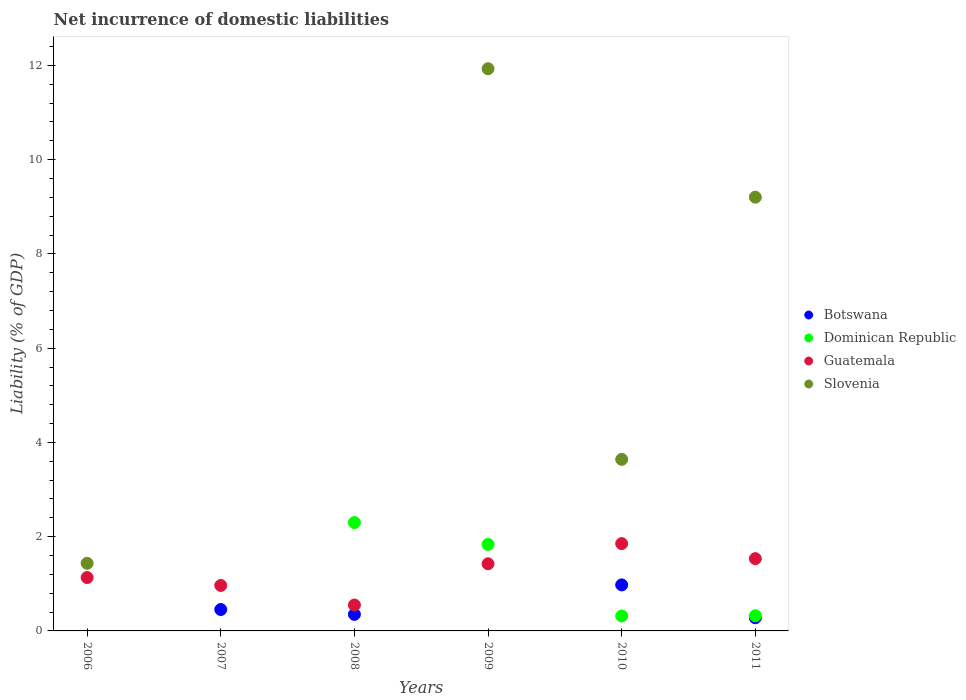How many different coloured dotlines are there?
Provide a succinct answer. 4. Across all years, what is the maximum net incurrence of domestic liabilities in Slovenia?
Provide a succinct answer. 11.93. Across all years, what is the minimum net incurrence of domestic liabilities in Slovenia?
Offer a very short reply. 0. What is the total net incurrence of domestic liabilities in Guatemala in the graph?
Your answer should be very brief. 7.46. What is the difference between the net incurrence of domestic liabilities in Botswana in 2008 and that in 2010?
Provide a succinct answer. -0.63. What is the difference between the net incurrence of domestic liabilities in Botswana in 2010 and the net incurrence of domestic liabilities in Dominican Republic in 2007?
Provide a succinct answer. 0.98. What is the average net incurrence of domestic liabilities in Slovenia per year?
Offer a terse response. 4.37. In the year 2010, what is the difference between the net incurrence of domestic liabilities in Dominican Republic and net incurrence of domestic liabilities in Guatemala?
Your answer should be compact. -1.54. What is the ratio of the net incurrence of domestic liabilities in Guatemala in 2008 to that in 2010?
Ensure brevity in your answer.  0.3. Is the net incurrence of domestic liabilities in Dominican Republic in 2010 less than that in 2011?
Your answer should be compact. Yes. What is the difference between the highest and the second highest net incurrence of domestic liabilities in Dominican Republic?
Make the answer very short. 0.46. What is the difference between the highest and the lowest net incurrence of domestic liabilities in Guatemala?
Your response must be concise. 1.3. In how many years, is the net incurrence of domestic liabilities in Botswana greater than the average net incurrence of domestic liabilities in Botswana taken over all years?
Your response must be concise. 3. Is it the case that in every year, the sum of the net incurrence of domestic liabilities in Slovenia and net incurrence of domestic liabilities in Dominican Republic  is greater than the net incurrence of domestic liabilities in Guatemala?
Provide a short and direct response. No. Does the net incurrence of domestic liabilities in Botswana monotonically increase over the years?
Your response must be concise. No. Is the net incurrence of domestic liabilities in Botswana strictly less than the net incurrence of domestic liabilities in Guatemala over the years?
Ensure brevity in your answer.  Yes. How many years are there in the graph?
Your answer should be very brief. 6. Does the graph contain any zero values?
Your response must be concise. Yes. Where does the legend appear in the graph?
Give a very brief answer. Center right. How are the legend labels stacked?
Make the answer very short. Vertical. What is the title of the graph?
Make the answer very short. Net incurrence of domestic liabilities. Does "Pakistan" appear as one of the legend labels in the graph?
Keep it short and to the point. No. What is the label or title of the Y-axis?
Ensure brevity in your answer.  Liability (% of GDP). What is the Liability (% of GDP) in Botswana in 2006?
Your answer should be compact. 0. What is the Liability (% of GDP) in Guatemala in 2006?
Your answer should be compact. 1.13. What is the Liability (% of GDP) of Slovenia in 2006?
Your response must be concise. 1.43. What is the Liability (% of GDP) in Botswana in 2007?
Provide a short and direct response. 0.45. What is the Liability (% of GDP) of Guatemala in 2007?
Your answer should be compact. 0.96. What is the Liability (% of GDP) of Botswana in 2008?
Offer a terse response. 0.35. What is the Liability (% of GDP) in Dominican Republic in 2008?
Your answer should be compact. 2.3. What is the Liability (% of GDP) of Guatemala in 2008?
Your response must be concise. 0.55. What is the Liability (% of GDP) in Slovenia in 2008?
Ensure brevity in your answer.  0. What is the Liability (% of GDP) of Dominican Republic in 2009?
Provide a succinct answer. 1.84. What is the Liability (% of GDP) of Guatemala in 2009?
Keep it short and to the point. 1.42. What is the Liability (% of GDP) in Slovenia in 2009?
Offer a very short reply. 11.93. What is the Liability (% of GDP) of Botswana in 2010?
Provide a short and direct response. 0.98. What is the Liability (% of GDP) of Dominican Republic in 2010?
Your answer should be compact. 0.32. What is the Liability (% of GDP) of Guatemala in 2010?
Provide a succinct answer. 1.85. What is the Liability (% of GDP) of Slovenia in 2010?
Give a very brief answer. 3.64. What is the Liability (% of GDP) of Botswana in 2011?
Offer a terse response. 0.28. What is the Liability (% of GDP) in Dominican Republic in 2011?
Provide a short and direct response. 0.32. What is the Liability (% of GDP) in Guatemala in 2011?
Provide a succinct answer. 1.53. What is the Liability (% of GDP) of Slovenia in 2011?
Offer a very short reply. 9.2. Across all years, what is the maximum Liability (% of GDP) in Botswana?
Your answer should be very brief. 0.98. Across all years, what is the maximum Liability (% of GDP) of Dominican Republic?
Your answer should be very brief. 2.3. Across all years, what is the maximum Liability (% of GDP) in Guatemala?
Provide a succinct answer. 1.85. Across all years, what is the maximum Liability (% of GDP) in Slovenia?
Ensure brevity in your answer.  11.93. Across all years, what is the minimum Liability (% of GDP) of Guatemala?
Your response must be concise. 0.55. What is the total Liability (% of GDP) in Botswana in the graph?
Keep it short and to the point. 2.06. What is the total Liability (% of GDP) in Dominican Republic in the graph?
Your response must be concise. 4.77. What is the total Liability (% of GDP) of Guatemala in the graph?
Give a very brief answer. 7.46. What is the total Liability (% of GDP) of Slovenia in the graph?
Offer a very short reply. 26.21. What is the difference between the Liability (% of GDP) of Guatemala in 2006 and that in 2007?
Offer a terse response. 0.17. What is the difference between the Liability (% of GDP) in Guatemala in 2006 and that in 2008?
Provide a short and direct response. 0.58. What is the difference between the Liability (% of GDP) in Guatemala in 2006 and that in 2009?
Ensure brevity in your answer.  -0.29. What is the difference between the Liability (% of GDP) in Slovenia in 2006 and that in 2009?
Keep it short and to the point. -10.5. What is the difference between the Liability (% of GDP) of Guatemala in 2006 and that in 2010?
Your answer should be compact. -0.72. What is the difference between the Liability (% of GDP) of Slovenia in 2006 and that in 2010?
Offer a terse response. -2.21. What is the difference between the Liability (% of GDP) in Guatemala in 2006 and that in 2011?
Ensure brevity in your answer.  -0.4. What is the difference between the Liability (% of GDP) of Slovenia in 2006 and that in 2011?
Your response must be concise. -7.77. What is the difference between the Liability (% of GDP) of Botswana in 2007 and that in 2008?
Your response must be concise. 0.1. What is the difference between the Liability (% of GDP) of Guatemala in 2007 and that in 2008?
Your response must be concise. 0.42. What is the difference between the Liability (% of GDP) in Guatemala in 2007 and that in 2009?
Your answer should be very brief. -0.46. What is the difference between the Liability (% of GDP) in Botswana in 2007 and that in 2010?
Offer a terse response. -0.52. What is the difference between the Liability (% of GDP) in Guatemala in 2007 and that in 2010?
Keep it short and to the point. -0.89. What is the difference between the Liability (% of GDP) of Botswana in 2007 and that in 2011?
Your response must be concise. 0.17. What is the difference between the Liability (% of GDP) of Guatemala in 2007 and that in 2011?
Offer a very short reply. -0.57. What is the difference between the Liability (% of GDP) of Dominican Republic in 2008 and that in 2009?
Offer a very short reply. 0.46. What is the difference between the Liability (% of GDP) in Guatemala in 2008 and that in 2009?
Offer a very short reply. -0.88. What is the difference between the Liability (% of GDP) of Botswana in 2008 and that in 2010?
Give a very brief answer. -0.63. What is the difference between the Liability (% of GDP) in Dominican Republic in 2008 and that in 2010?
Your answer should be compact. 1.98. What is the difference between the Liability (% of GDP) in Guatemala in 2008 and that in 2010?
Make the answer very short. -1.3. What is the difference between the Liability (% of GDP) in Botswana in 2008 and that in 2011?
Offer a terse response. 0.07. What is the difference between the Liability (% of GDP) of Dominican Republic in 2008 and that in 2011?
Keep it short and to the point. 1.98. What is the difference between the Liability (% of GDP) of Guatemala in 2008 and that in 2011?
Provide a short and direct response. -0.98. What is the difference between the Liability (% of GDP) of Dominican Republic in 2009 and that in 2010?
Your response must be concise. 1.52. What is the difference between the Liability (% of GDP) in Guatemala in 2009 and that in 2010?
Give a very brief answer. -0.43. What is the difference between the Liability (% of GDP) in Slovenia in 2009 and that in 2010?
Ensure brevity in your answer.  8.29. What is the difference between the Liability (% of GDP) of Dominican Republic in 2009 and that in 2011?
Provide a succinct answer. 1.51. What is the difference between the Liability (% of GDP) in Guatemala in 2009 and that in 2011?
Your answer should be compact. -0.11. What is the difference between the Liability (% of GDP) of Slovenia in 2009 and that in 2011?
Offer a very short reply. 2.73. What is the difference between the Liability (% of GDP) in Botswana in 2010 and that in 2011?
Ensure brevity in your answer.  0.7. What is the difference between the Liability (% of GDP) in Dominican Republic in 2010 and that in 2011?
Make the answer very short. -0. What is the difference between the Liability (% of GDP) of Guatemala in 2010 and that in 2011?
Keep it short and to the point. 0.32. What is the difference between the Liability (% of GDP) in Slovenia in 2010 and that in 2011?
Keep it short and to the point. -5.56. What is the difference between the Liability (% of GDP) of Guatemala in 2006 and the Liability (% of GDP) of Slovenia in 2009?
Offer a terse response. -10.8. What is the difference between the Liability (% of GDP) of Guatemala in 2006 and the Liability (% of GDP) of Slovenia in 2010?
Ensure brevity in your answer.  -2.51. What is the difference between the Liability (% of GDP) of Guatemala in 2006 and the Liability (% of GDP) of Slovenia in 2011?
Offer a terse response. -8.07. What is the difference between the Liability (% of GDP) in Botswana in 2007 and the Liability (% of GDP) in Dominican Republic in 2008?
Offer a terse response. -1.84. What is the difference between the Liability (% of GDP) of Botswana in 2007 and the Liability (% of GDP) of Guatemala in 2008?
Provide a short and direct response. -0.1. What is the difference between the Liability (% of GDP) of Botswana in 2007 and the Liability (% of GDP) of Dominican Republic in 2009?
Give a very brief answer. -1.38. What is the difference between the Liability (% of GDP) of Botswana in 2007 and the Liability (% of GDP) of Guatemala in 2009?
Your answer should be very brief. -0.97. What is the difference between the Liability (% of GDP) of Botswana in 2007 and the Liability (% of GDP) of Slovenia in 2009?
Offer a very short reply. -11.48. What is the difference between the Liability (% of GDP) in Guatemala in 2007 and the Liability (% of GDP) in Slovenia in 2009?
Provide a succinct answer. -10.97. What is the difference between the Liability (% of GDP) of Botswana in 2007 and the Liability (% of GDP) of Dominican Republic in 2010?
Provide a short and direct response. 0.14. What is the difference between the Liability (% of GDP) of Botswana in 2007 and the Liability (% of GDP) of Guatemala in 2010?
Give a very brief answer. -1.4. What is the difference between the Liability (% of GDP) in Botswana in 2007 and the Liability (% of GDP) in Slovenia in 2010?
Provide a succinct answer. -3.19. What is the difference between the Liability (% of GDP) of Guatemala in 2007 and the Liability (% of GDP) of Slovenia in 2010?
Ensure brevity in your answer.  -2.68. What is the difference between the Liability (% of GDP) of Botswana in 2007 and the Liability (% of GDP) of Dominican Republic in 2011?
Ensure brevity in your answer.  0.13. What is the difference between the Liability (% of GDP) in Botswana in 2007 and the Liability (% of GDP) in Guatemala in 2011?
Offer a very short reply. -1.08. What is the difference between the Liability (% of GDP) of Botswana in 2007 and the Liability (% of GDP) of Slovenia in 2011?
Your answer should be compact. -8.75. What is the difference between the Liability (% of GDP) of Guatemala in 2007 and the Liability (% of GDP) of Slovenia in 2011?
Offer a very short reply. -8.24. What is the difference between the Liability (% of GDP) in Botswana in 2008 and the Liability (% of GDP) in Dominican Republic in 2009?
Ensure brevity in your answer.  -1.48. What is the difference between the Liability (% of GDP) in Botswana in 2008 and the Liability (% of GDP) in Guatemala in 2009?
Your answer should be very brief. -1.07. What is the difference between the Liability (% of GDP) of Botswana in 2008 and the Liability (% of GDP) of Slovenia in 2009?
Your answer should be very brief. -11.58. What is the difference between the Liability (% of GDP) in Dominican Republic in 2008 and the Liability (% of GDP) in Guatemala in 2009?
Your response must be concise. 0.87. What is the difference between the Liability (% of GDP) of Dominican Republic in 2008 and the Liability (% of GDP) of Slovenia in 2009?
Keep it short and to the point. -9.63. What is the difference between the Liability (% of GDP) of Guatemala in 2008 and the Liability (% of GDP) of Slovenia in 2009?
Provide a succinct answer. -11.38. What is the difference between the Liability (% of GDP) of Botswana in 2008 and the Liability (% of GDP) of Dominican Republic in 2010?
Provide a short and direct response. 0.03. What is the difference between the Liability (% of GDP) in Botswana in 2008 and the Liability (% of GDP) in Guatemala in 2010?
Make the answer very short. -1.5. What is the difference between the Liability (% of GDP) of Botswana in 2008 and the Liability (% of GDP) of Slovenia in 2010?
Your answer should be very brief. -3.29. What is the difference between the Liability (% of GDP) of Dominican Republic in 2008 and the Liability (% of GDP) of Guatemala in 2010?
Give a very brief answer. 0.45. What is the difference between the Liability (% of GDP) of Dominican Republic in 2008 and the Liability (% of GDP) of Slovenia in 2010?
Make the answer very short. -1.34. What is the difference between the Liability (% of GDP) in Guatemala in 2008 and the Liability (% of GDP) in Slovenia in 2010?
Provide a succinct answer. -3.09. What is the difference between the Liability (% of GDP) of Botswana in 2008 and the Liability (% of GDP) of Dominican Republic in 2011?
Provide a succinct answer. 0.03. What is the difference between the Liability (% of GDP) of Botswana in 2008 and the Liability (% of GDP) of Guatemala in 2011?
Make the answer very short. -1.18. What is the difference between the Liability (% of GDP) in Botswana in 2008 and the Liability (% of GDP) in Slovenia in 2011?
Provide a succinct answer. -8.85. What is the difference between the Liability (% of GDP) of Dominican Republic in 2008 and the Liability (% of GDP) of Guatemala in 2011?
Your answer should be very brief. 0.77. What is the difference between the Liability (% of GDP) in Dominican Republic in 2008 and the Liability (% of GDP) in Slovenia in 2011?
Your answer should be very brief. -6.9. What is the difference between the Liability (% of GDP) of Guatemala in 2008 and the Liability (% of GDP) of Slovenia in 2011?
Offer a very short reply. -8.65. What is the difference between the Liability (% of GDP) in Dominican Republic in 2009 and the Liability (% of GDP) in Guatemala in 2010?
Provide a succinct answer. -0.02. What is the difference between the Liability (% of GDP) in Dominican Republic in 2009 and the Liability (% of GDP) in Slovenia in 2010?
Your answer should be compact. -1.8. What is the difference between the Liability (% of GDP) of Guatemala in 2009 and the Liability (% of GDP) of Slovenia in 2010?
Your response must be concise. -2.22. What is the difference between the Liability (% of GDP) in Dominican Republic in 2009 and the Liability (% of GDP) in Guatemala in 2011?
Your answer should be compact. 0.3. What is the difference between the Liability (% of GDP) of Dominican Republic in 2009 and the Liability (% of GDP) of Slovenia in 2011?
Provide a succinct answer. -7.37. What is the difference between the Liability (% of GDP) in Guatemala in 2009 and the Liability (% of GDP) in Slovenia in 2011?
Offer a very short reply. -7.78. What is the difference between the Liability (% of GDP) of Botswana in 2010 and the Liability (% of GDP) of Dominican Republic in 2011?
Your answer should be compact. 0.66. What is the difference between the Liability (% of GDP) of Botswana in 2010 and the Liability (% of GDP) of Guatemala in 2011?
Provide a short and direct response. -0.56. What is the difference between the Liability (% of GDP) in Botswana in 2010 and the Liability (% of GDP) in Slovenia in 2011?
Offer a very short reply. -8.23. What is the difference between the Liability (% of GDP) of Dominican Republic in 2010 and the Liability (% of GDP) of Guatemala in 2011?
Provide a succinct answer. -1.22. What is the difference between the Liability (% of GDP) in Dominican Republic in 2010 and the Liability (% of GDP) in Slovenia in 2011?
Ensure brevity in your answer.  -8.89. What is the difference between the Liability (% of GDP) in Guatemala in 2010 and the Liability (% of GDP) in Slovenia in 2011?
Your answer should be very brief. -7.35. What is the average Liability (% of GDP) of Botswana per year?
Offer a very short reply. 0.34. What is the average Liability (% of GDP) in Dominican Republic per year?
Provide a short and direct response. 0.8. What is the average Liability (% of GDP) of Guatemala per year?
Provide a succinct answer. 1.24. What is the average Liability (% of GDP) of Slovenia per year?
Offer a terse response. 4.37. In the year 2006, what is the difference between the Liability (% of GDP) in Guatemala and Liability (% of GDP) in Slovenia?
Your response must be concise. -0.3. In the year 2007, what is the difference between the Liability (% of GDP) of Botswana and Liability (% of GDP) of Guatemala?
Keep it short and to the point. -0.51. In the year 2008, what is the difference between the Liability (% of GDP) in Botswana and Liability (% of GDP) in Dominican Republic?
Your answer should be compact. -1.95. In the year 2008, what is the difference between the Liability (% of GDP) in Botswana and Liability (% of GDP) in Guatemala?
Provide a short and direct response. -0.2. In the year 2008, what is the difference between the Liability (% of GDP) in Dominican Republic and Liability (% of GDP) in Guatemala?
Your response must be concise. 1.75. In the year 2009, what is the difference between the Liability (% of GDP) of Dominican Republic and Liability (% of GDP) of Guatemala?
Offer a very short reply. 0.41. In the year 2009, what is the difference between the Liability (% of GDP) of Dominican Republic and Liability (% of GDP) of Slovenia?
Keep it short and to the point. -10.09. In the year 2009, what is the difference between the Liability (% of GDP) of Guatemala and Liability (% of GDP) of Slovenia?
Ensure brevity in your answer.  -10.51. In the year 2010, what is the difference between the Liability (% of GDP) in Botswana and Liability (% of GDP) in Dominican Republic?
Keep it short and to the point. 0.66. In the year 2010, what is the difference between the Liability (% of GDP) of Botswana and Liability (% of GDP) of Guatemala?
Your answer should be very brief. -0.88. In the year 2010, what is the difference between the Liability (% of GDP) in Botswana and Liability (% of GDP) in Slovenia?
Give a very brief answer. -2.66. In the year 2010, what is the difference between the Liability (% of GDP) of Dominican Republic and Liability (% of GDP) of Guatemala?
Provide a short and direct response. -1.54. In the year 2010, what is the difference between the Liability (% of GDP) of Dominican Republic and Liability (% of GDP) of Slovenia?
Offer a terse response. -3.32. In the year 2010, what is the difference between the Liability (% of GDP) in Guatemala and Liability (% of GDP) in Slovenia?
Make the answer very short. -1.79. In the year 2011, what is the difference between the Liability (% of GDP) of Botswana and Liability (% of GDP) of Dominican Republic?
Provide a short and direct response. -0.04. In the year 2011, what is the difference between the Liability (% of GDP) of Botswana and Liability (% of GDP) of Guatemala?
Your answer should be compact. -1.25. In the year 2011, what is the difference between the Liability (% of GDP) in Botswana and Liability (% of GDP) in Slovenia?
Your response must be concise. -8.92. In the year 2011, what is the difference between the Liability (% of GDP) in Dominican Republic and Liability (% of GDP) in Guatemala?
Give a very brief answer. -1.21. In the year 2011, what is the difference between the Liability (% of GDP) in Dominican Republic and Liability (% of GDP) in Slovenia?
Offer a terse response. -8.88. In the year 2011, what is the difference between the Liability (% of GDP) in Guatemala and Liability (% of GDP) in Slovenia?
Provide a short and direct response. -7.67. What is the ratio of the Liability (% of GDP) in Guatemala in 2006 to that in 2007?
Your answer should be very brief. 1.17. What is the ratio of the Liability (% of GDP) of Guatemala in 2006 to that in 2008?
Provide a short and direct response. 2.06. What is the ratio of the Liability (% of GDP) of Guatemala in 2006 to that in 2009?
Your answer should be compact. 0.8. What is the ratio of the Liability (% of GDP) in Slovenia in 2006 to that in 2009?
Offer a terse response. 0.12. What is the ratio of the Liability (% of GDP) in Guatemala in 2006 to that in 2010?
Provide a succinct answer. 0.61. What is the ratio of the Liability (% of GDP) in Slovenia in 2006 to that in 2010?
Your answer should be compact. 0.39. What is the ratio of the Liability (% of GDP) of Guatemala in 2006 to that in 2011?
Keep it short and to the point. 0.74. What is the ratio of the Liability (% of GDP) in Slovenia in 2006 to that in 2011?
Offer a very short reply. 0.16. What is the ratio of the Liability (% of GDP) in Botswana in 2007 to that in 2008?
Offer a very short reply. 1.29. What is the ratio of the Liability (% of GDP) of Guatemala in 2007 to that in 2008?
Your answer should be compact. 1.76. What is the ratio of the Liability (% of GDP) in Guatemala in 2007 to that in 2009?
Your answer should be compact. 0.68. What is the ratio of the Liability (% of GDP) of Botswana in 2007 to that in 2010?
Make the answer very short. 0.46. What is the ratio of the Liability (% of GDP) in Guatemala in 2007 to that in 2010?
Make the answer very short. 0.52. What is the ratio of the Liability (% of GDP) in Botswana in 2007 to that in 2011?
Provide a short and direct response. 1.62. What is the ratio of the Liability (% of GDP) in Guatemala in 2007 to that in 2011?
Your answer should be compact. 0.63. What is the ratio of the Liability (% of GDP) in Dominican Republic in 2008 to that in 2009?
Your answer should be very brief. 1.25. What is the ratio of the Liability (% of GDP) of Guatemala in 2008 to that in 2009?
Offer a very short reply. 0.39. What is the ratio of the Liability (% of GDP) of Botswana in 2008 to that in 2010?
Offer a very short reply. 0.36. What is the ratio of the Liability (% of GDP) of Dominican Republic in 2008 to that in 2010?
Offer a very short reply. 7.25. What is the ratio of the Liability (% of GDP) of Guatemala in 2008 to that in 2010?
Keep it short and to the point. 0.3. What is the ratio of the Liability (% of GDP) of Botswana in 2008 to that in 2011?
Your answer should be compact. 1.26. What is the ratio of the Liability (% of GDP) in Dominican Republic in 2008 to that in 2011?
Provide a succinct answer. 7.16. What is the ratio of the Liability (% of GDP) of Guatemala in 2008 to that in 2011?
Ensure brevity in your answer.  0.36. What is the ratio of the Liability (% of GDP) in Dominican Republic in 2009 to that in 2010?
Provide a short and direct response. 5.79. What is the ratio of the Liability (% of GDP) in Guatemala in 2009 to that in 2010?
Provide a short and direct response. 0.77. What is the ratio of the Liability (% of GDP) in Slovenia in 2009 to that in 2010?
Provide a short and direct response. 3.28. What is the ratio of the Liability (% of GDP) of Dominican Republic in 2009 to that in 2011?
Your response must be concise. 5.72. What is the ratio of the Liability (% of GDP) in Guatemala in 2009 to that in 2011?
Your answer should be very brief. 0.93. What is the ratio of the Liability (% of GDP) in Slovenia in 2009 to that in 2011?
Make the answer very short. 1.3. What is the ratio of the Liability (% of GDP) in Botswana in 2010 to that in 2011?
Provide a succinct answer. 3.5. What is the ratio of the Liability (% of GDP) in Guatemala in 2010 to that in 2011?
Offer a terse response. 1.21. What is the ratio of the Liability (% of GDP) of Slovenia in 2010 to that in 2011?
Make the answer very short. 0.4. What is the difference between the highest and the second highest Liability (% of GDP) in Botswana?
Your answer should be very brief. 0.52. What is the difference between the highest and the second highest Liability (% of GDP) of Dominican Republic?
Give a very brief answer. 0.46. What is the difference between the highest and the second highest Liability (% of GDP) in Guatemala?
Provide a succinct answer. 0.32. What is the difference between the highest and the second highest Liability (% of GDP) in Slovenia?
Your answer should be compact. 2.73. What is the difference between the highest and the lowest Liability (% of GDP) of Botswana?
Your answer should be very brief. 0.98. What is the difference between the highest and the lowest Liability (% of GDP) of Dominican Republic?
Your answer should be compact. 2.3. What is the difference between the highest and the lowest Liability (% of GDP) of Guatemala?
Give a very brief answer. 1.3. What is the difference between the highest and the lowest Liability (% of GDP) of Slovenia?
Ensure brevity in your answer.  11.93. 